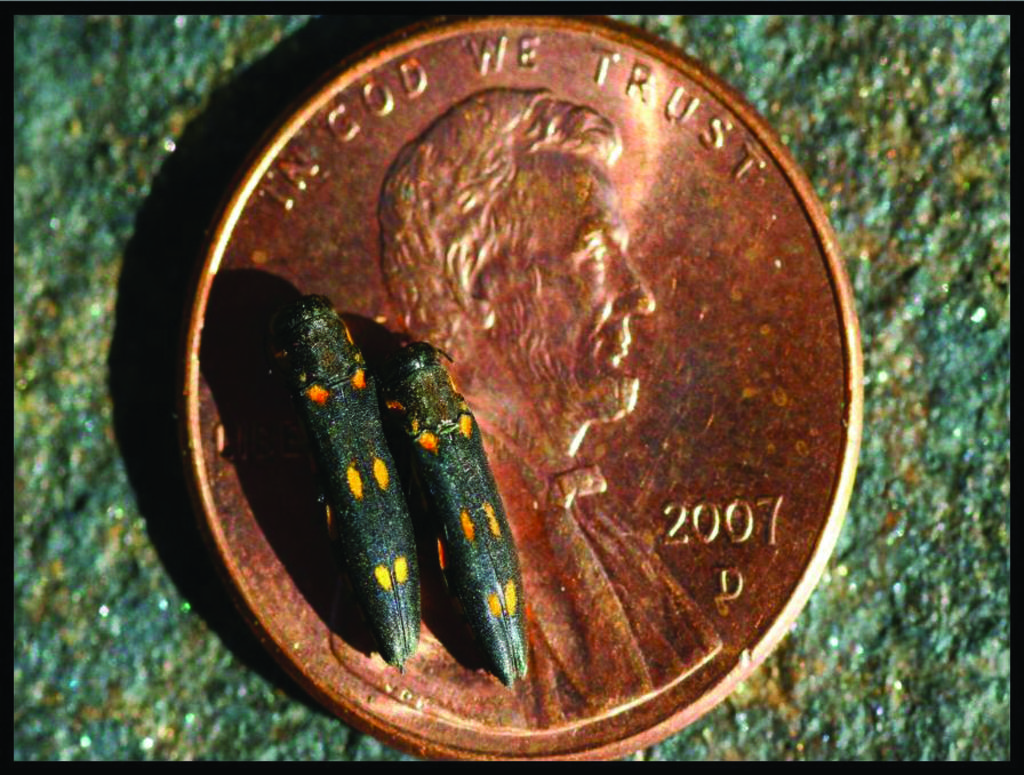What year is this penny?
Your answer should be compact. 2007. In who do we trust?
Offer a very short reply. God. 